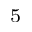Convert formula to latex. <formula><loc_0><loc_0><loc_500><loc_500>^ { 5 }</formula> 